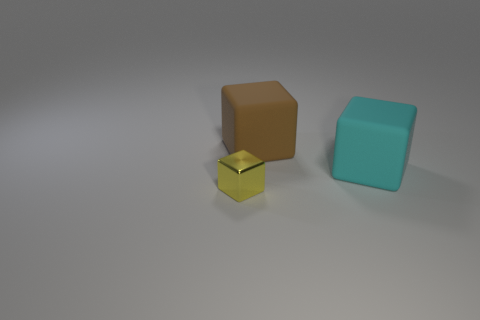Can you explain the context of this image? What might these objects be used for? This image seems to depict three geometric shapes placed together, possibly for a display or a visual composition exercise. The objects could be used for educational purposes, for example, teaching geometry or colors, or they could be part of a decor set to create a minimalistic aesthetic in a space. 